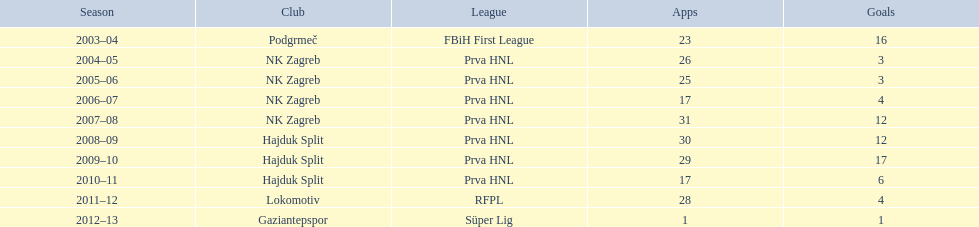What were the names of each club where more than 15 goals were scored in a single season? Podgrmeč, Hajduk Split. 